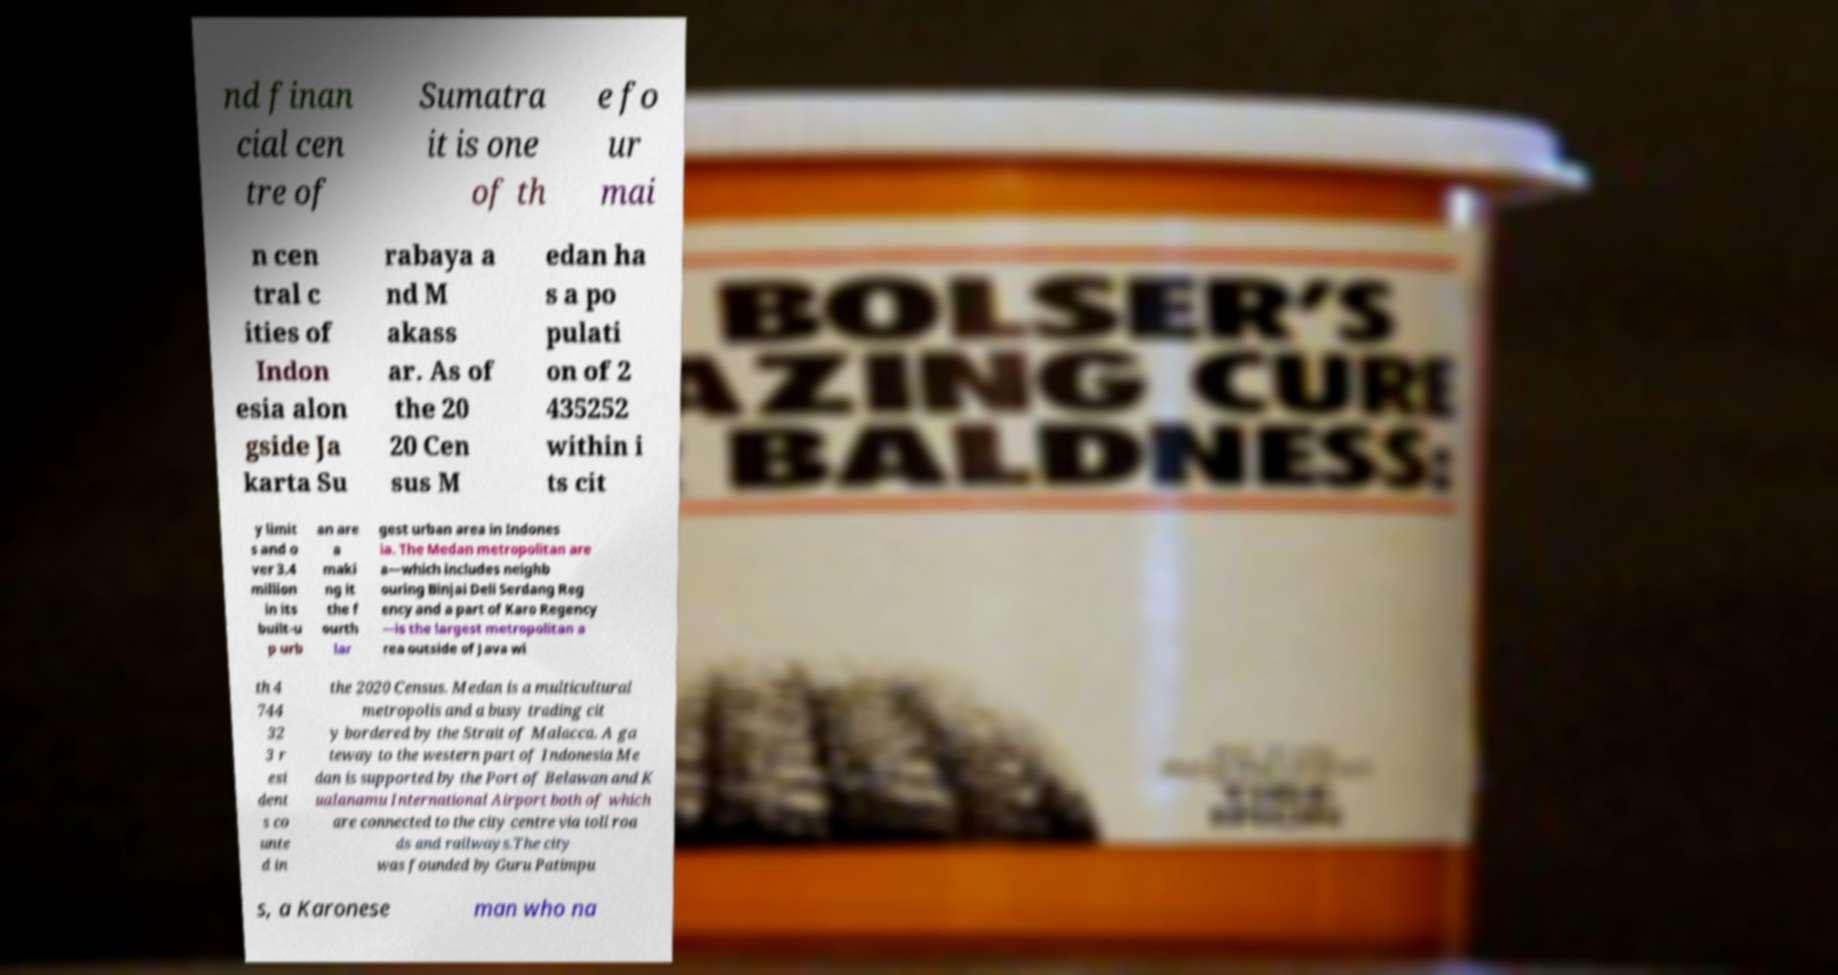Please identify and transcribe the text found in this image. nd finan cial cen tre of Sumatra it is one of th e fo ur mai n cen tral c ities of Indon esia alon gside Ja karta Su rabaya a nd M akass ar. As of the 20 20 Cen sus M edan ha s a po pulati on of 2 435252 within i ts cit y limit s and o ver 3.4 million in its built-u p urb an are a maki ng it the f ourth lar gest urban area in Indones ia. The Medan metropolitan are a—which includes neighb ouring Binjai Deli Serdang Reg ency and a part of Karo Regency —is the largest metropolitan a rea outside of Java wi th 4 744 32 3 r esi dent s co unte d in the 2020 Census. Medan is a multicultural metropolis and a busy trading cit y bordered by the Strait of Malacca. A ga teway to the western part of Indonesia Me dan is supported by the Port of Belawan and K ualanamu International Airport both of which are connected to the city centre via toll roa ds and railways.The city was founded by Guru Patimpu s, a Karonese man who na 